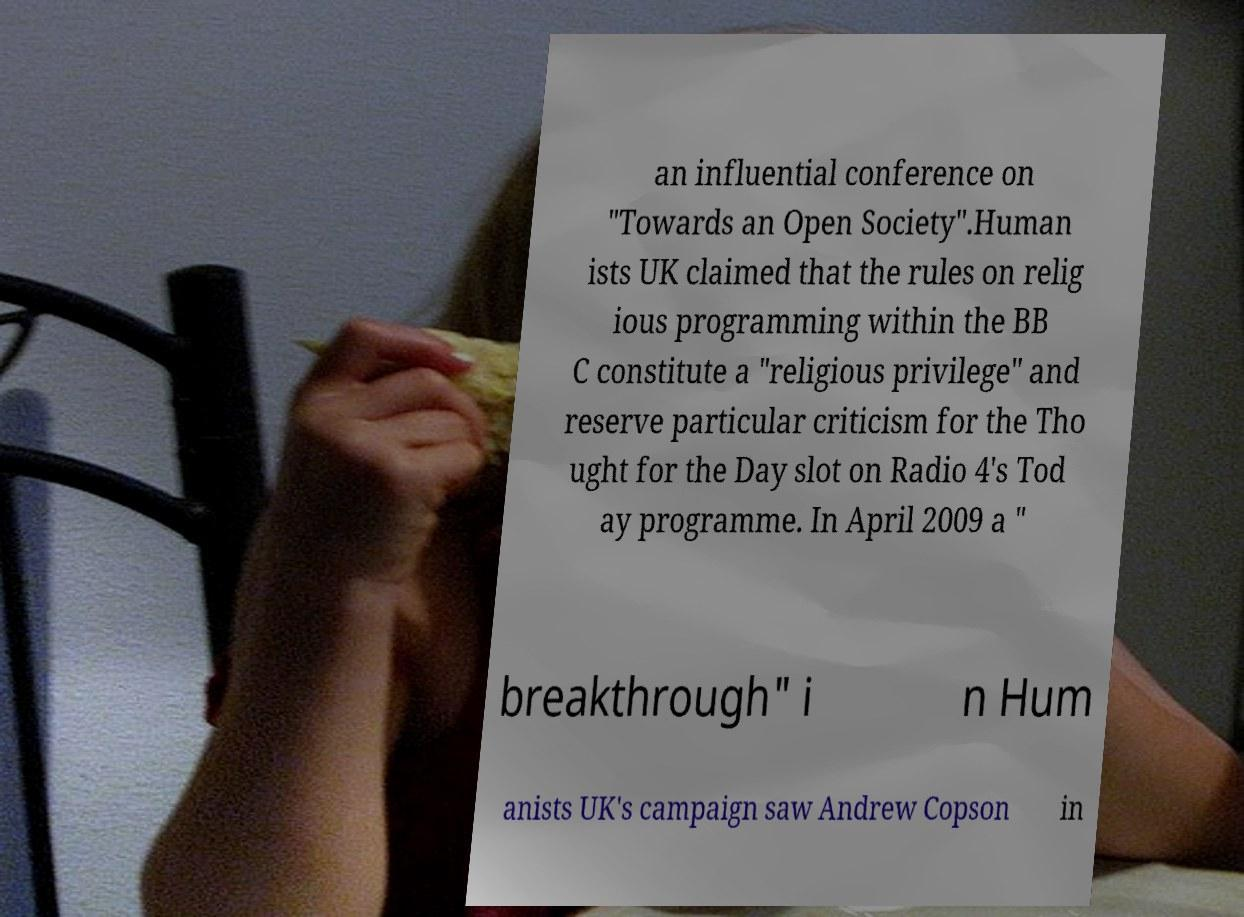There's text embedded in this image that I need extracted. Can you transcribe it verbatim? an influential conference on "Towards an Open Society".Human ists UK claimed that the rules on relig ious programming within the BB C constitute a "religious privilege" and reserve particular criticism for the Tho ught for the Day slot on Radio 4's Tod ay programme. In April 2009 a " breakthrough" i n Hum anists UK's campaign saw Andrew Copson in 